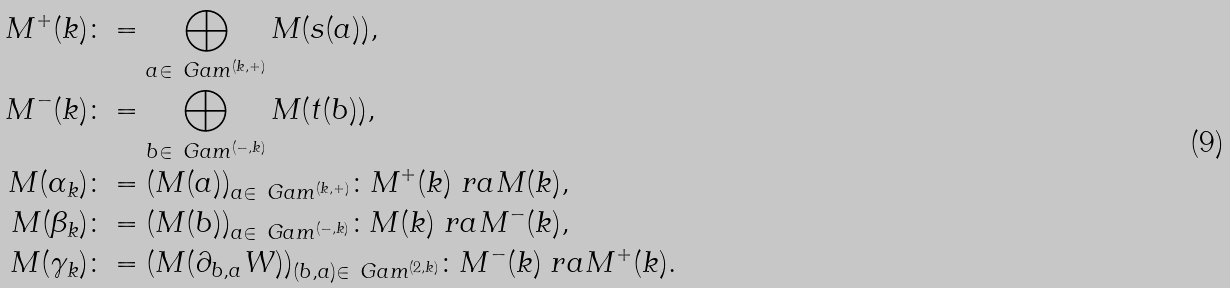<formula> <loc_0><loc_0><loc_500><loc_500>M ^ { + } ( k ) & \colon = \bigoplus _ { a \in \ G a m ^ { ( k , + ) } } M ( s ( a ) ) , \\ M ^ { - } ( k ) & \colon = \bigoplus _ { b \in \ G a m ^ { ( - , k ) } } M ( t ( b ) ) , \\ M ( \alpha _ { k } ) & \colon = ( M ( a ) ) _ { a \in \ G a m ^ { ( k , + ) } } \colon M ^ { + } ( k ) \ r a M ( k ) , \\ M ( \beta _ { k } ) & \colon = ( M ( b ) ) _ { a \in \ G a m ^ { ( - , k ) } } \colon M ( k ) \ r a M ^ { - } ( k ) , \\ M ( \gamma _ { k } ) & \colon = ( M ( \partial _ { b , a } W ) ) _ { ( b , a ) \in \ G a m ^ { ( 2 , k ) } } \colon M ^ { - } ( k ) \ r a M ^ { + } ( k ) .</formula> 